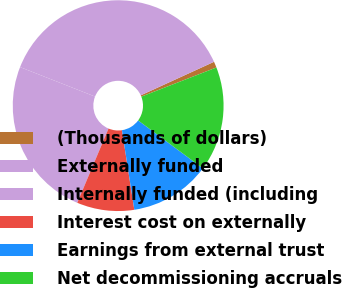<chart> <loc_0><loc_0><loc_500><loc_500><pie_chart><fcel>(Thousands of dollars)<fcel>Externally funded<fcel>Internally funded (including<fcel>Interest cost on externally<fcel>Earnings from external trust<fcel>Net decommissioning accruals<nl><fcel>0.93%<fcel>37.21%<fcel>24.62%<fcel>8.79%<fcel>12.41%<fcel>16.04%<nl></chart> 